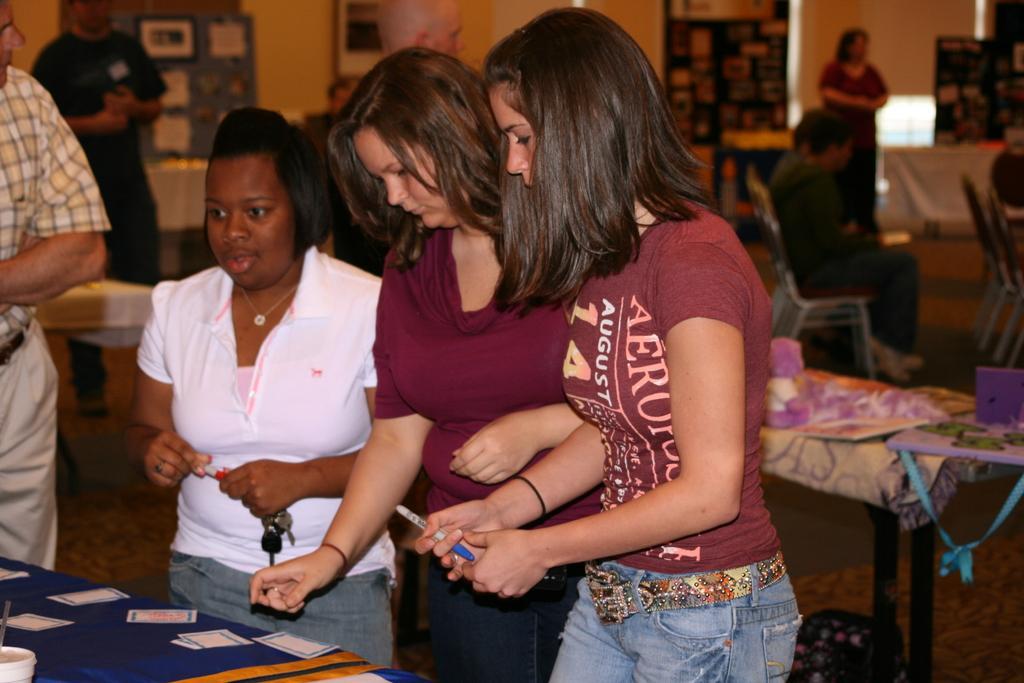Could you give a brief overview of what you see in this image? Few persons are standing,few persons are sitting on the chair. We can see tables and chairs,on the table we can see papers,cup. This is floor. On the background we can see wall. 